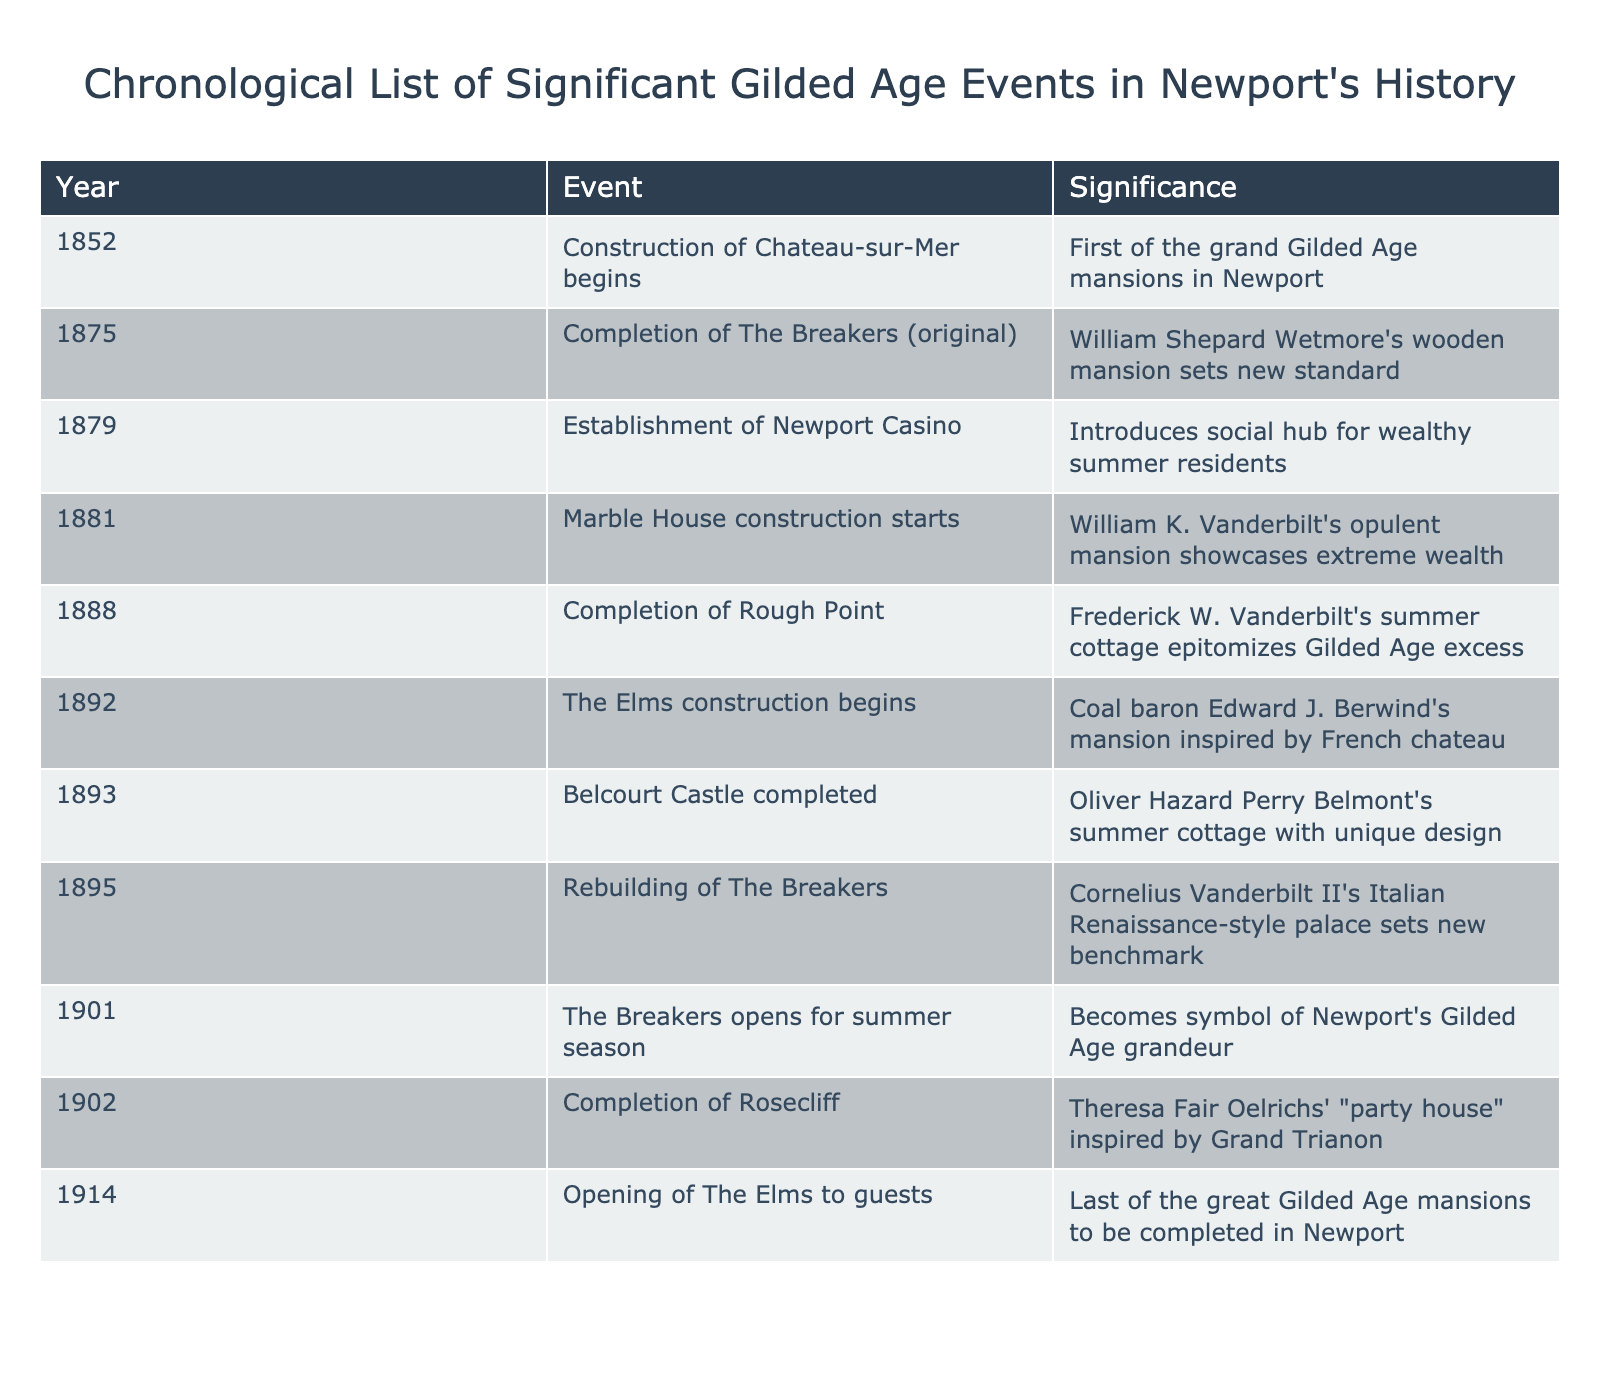What year did the construction of Chateau-sur-Mer begin? The table lists the year 1852 next to the event of Chateau-sur-Mer's construction beginning.
Answer: 1852 What significant event happened in 1901 in Newport? According to the table, the Breakers opened for the summer season, becoming a symbol of Newport's Gilded Age grandeur.
Answer: The Breakers opened for the summer season What is the significance of the completion of Rosecliff in 1902? The table indicates that Rosecliff, completed in 1902, was Theresa Fair Oelrichs' "party house" inspired by the Grand Trianon.
Answer: It's a "party house" inspired by the Grand Trianon Which mansion was completed last among the Gilded Age mansions listed? By looking at the table, the Elms opened to guests in 1914, making it the last of the great Gilded Age mansions completed in Newport.
Answer: The Elms opened to guests in 1914 How many years passed between the completion of The Breakers and the opening of Rosecliff? The Breakers was completed in 1895 and Rosecliff was completed in 1902. The difference is 1902 - 1895 = 7 years.
Answer: 7 years Was the Newport Casino established before or after the completion of Marble House? The table shows that the Newport Casino was established in 1879 and Marble House construction started in 1881. Therefore, it was established before.
Answer: Before What are the two events that occurred in the year 1892? From the table, it lists the beginning of The Elms construction and indicates no additional events in that year. So, there is only one significant event: The Elms construction begins.
Answer: The Elms construction begins Which mansion construction began in 1875 and what was its significance? The table indicates that in 1875, the original construction of The Breakers began, setting a new standard for Newport's grand mansions.
Answer: The Breakers; set a new standard for grand mansions How many years were between the completion of Rough Point and the opening of The Elms to guests? Rough Point was completed in 1888 and The Elms opened in 1914. Calculating the difference gives 1914 - 1888 = 26 years.
Answer: 26 years Is Marble House considered a mansion? The table states that Marble House showcases extreme wealth, which implies it is indeed considered a mansion.
Answer: Yes Which event marked the introduction of a social hub for wealthy residents, and when did it occur? The Newport Casino's establishment in 1879 is marked as the introduction of a social hub for wealthy summer residents according to the table.
Answer: Establishment of Newport Casino in 1879 